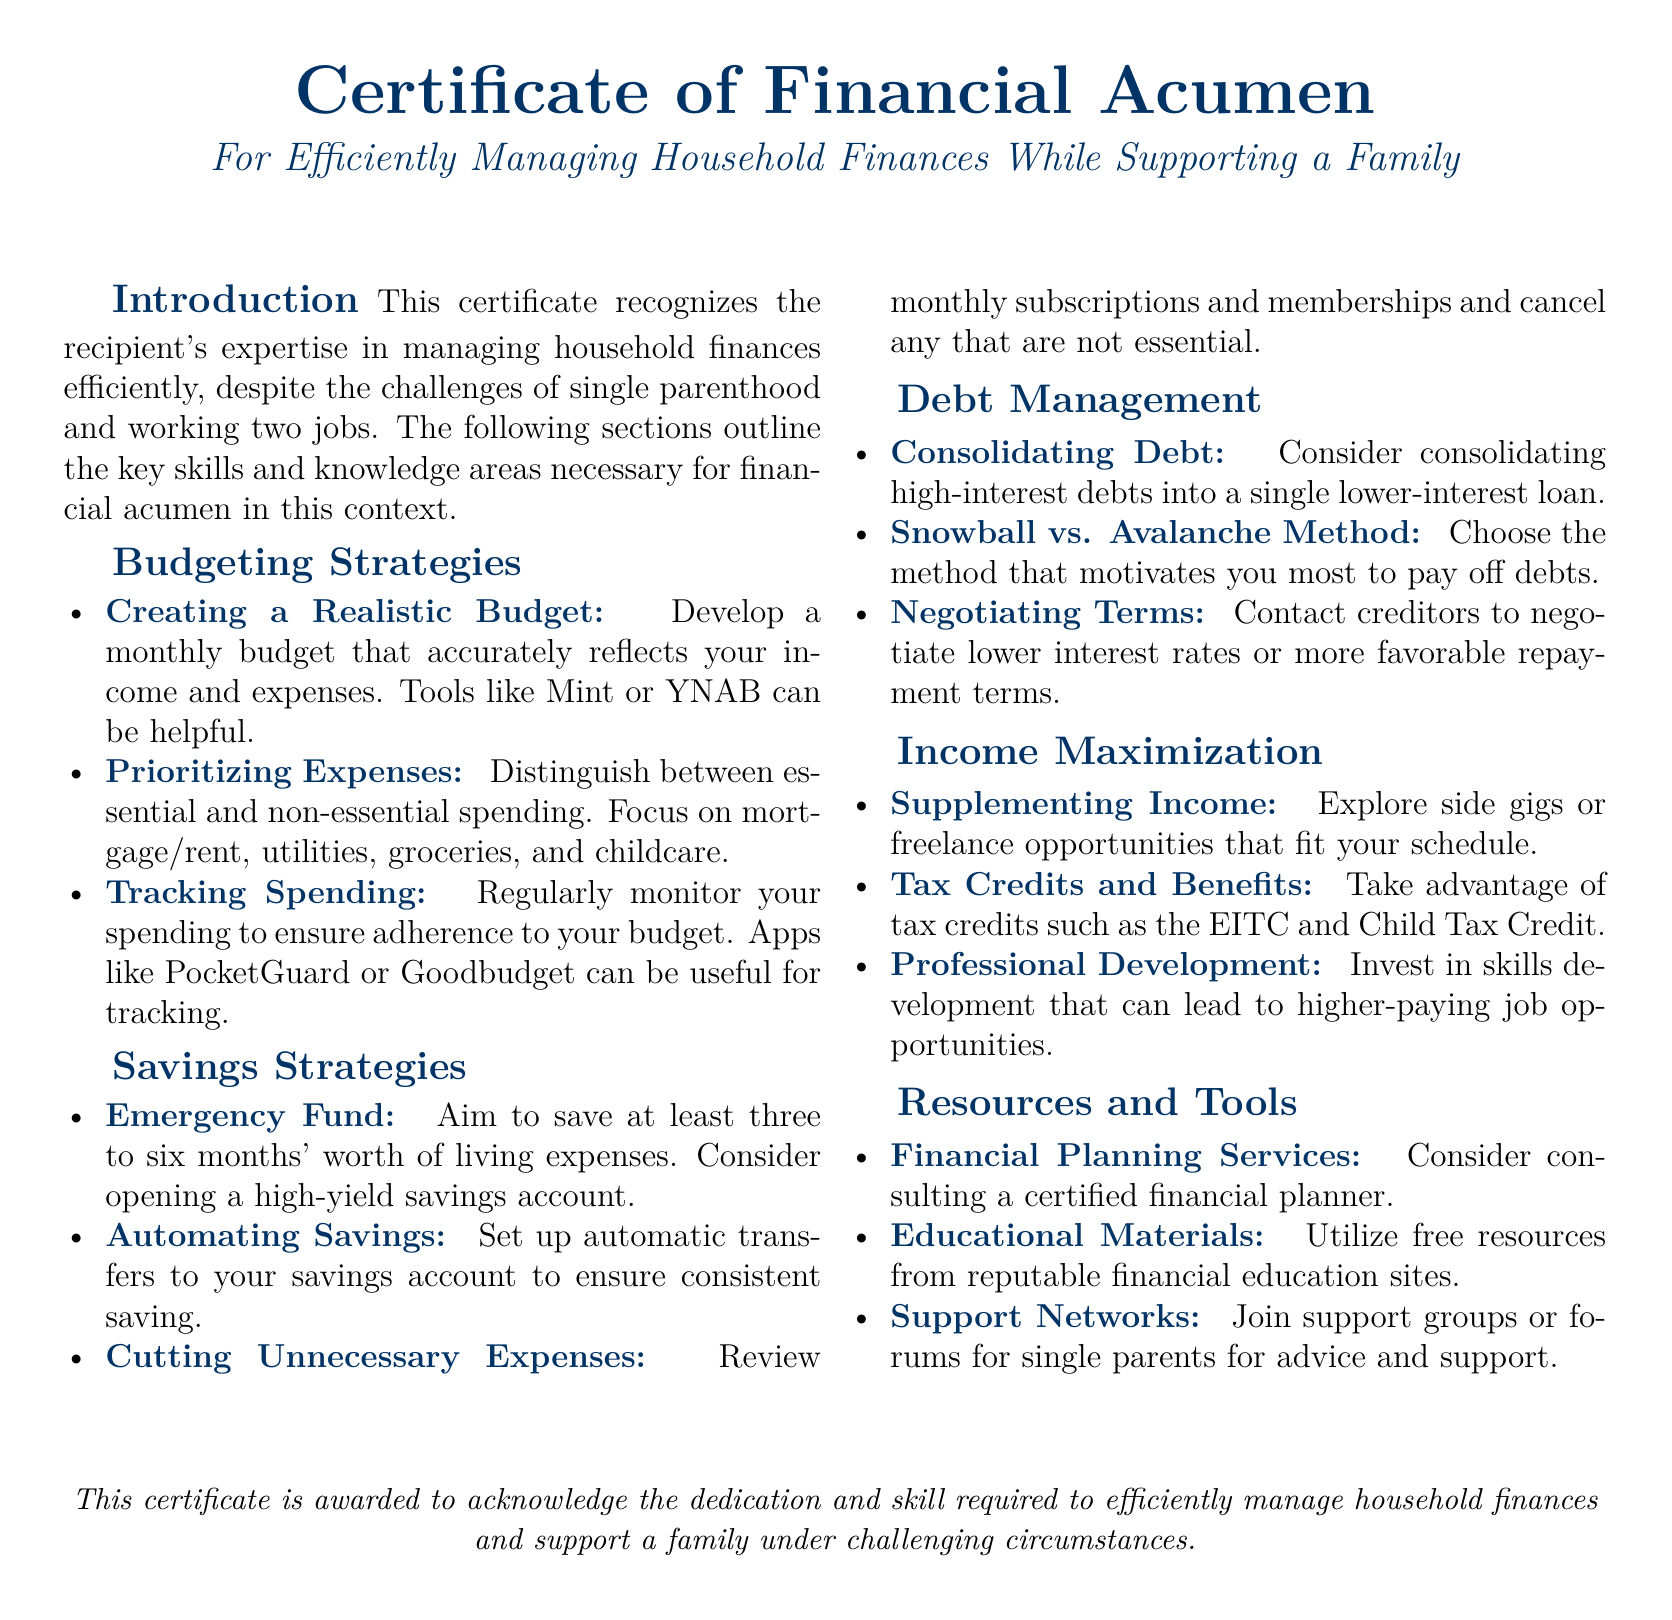What is the title of the certificate? The title is prominently displayed at the top of the document as "Certificate of Financial Acumen."
Answer: Certificate of Financial Acumen What is the primary focus of the certificate? The document states its primary focus is on "Efficiently Managing Household Finances While Supporting a Family."
Answer: Efficiently Managing Household Finances While Supporting a Family How many months' worth of living expenses should be saved for the emergency fund? The recommendation for the emergency fund is mentioned as "at least three to six months' worth of living expenses."
Answer: Three to six months Which budgeting tool is suggested for creating a realistic budget? The document suggests tools like "Mint or YNAB" for developing a monthly budget.
Answer: Mint or YNAB What strategy involves consolidating high-interest debts? The document refers to the "Consolidating Debt" strategy for managing debt effectively.
Answer: Consolidating Debt Name one method for debt management mentioned in the certificate. The document lists "Snowball vs. Avalanche Method" as methods for debt management.
Answer: Snowball vs. Avalanche Method What should be done to ensure consistent saving? The certificate recommends "automating savings" as a strategy for consistent saving.
Answer: Automating savings What type of planner does the document suggest considering? The document suggests considering "consulting a certified financial planner" for financial guidance.
Answer: Certified financial planner Which tax credit is mentioned in the context of income maximization? The document states to "take advantage of tax credits such as the EITC and Child Tax Credit."
Answer: EITC and Child Tax Credit 